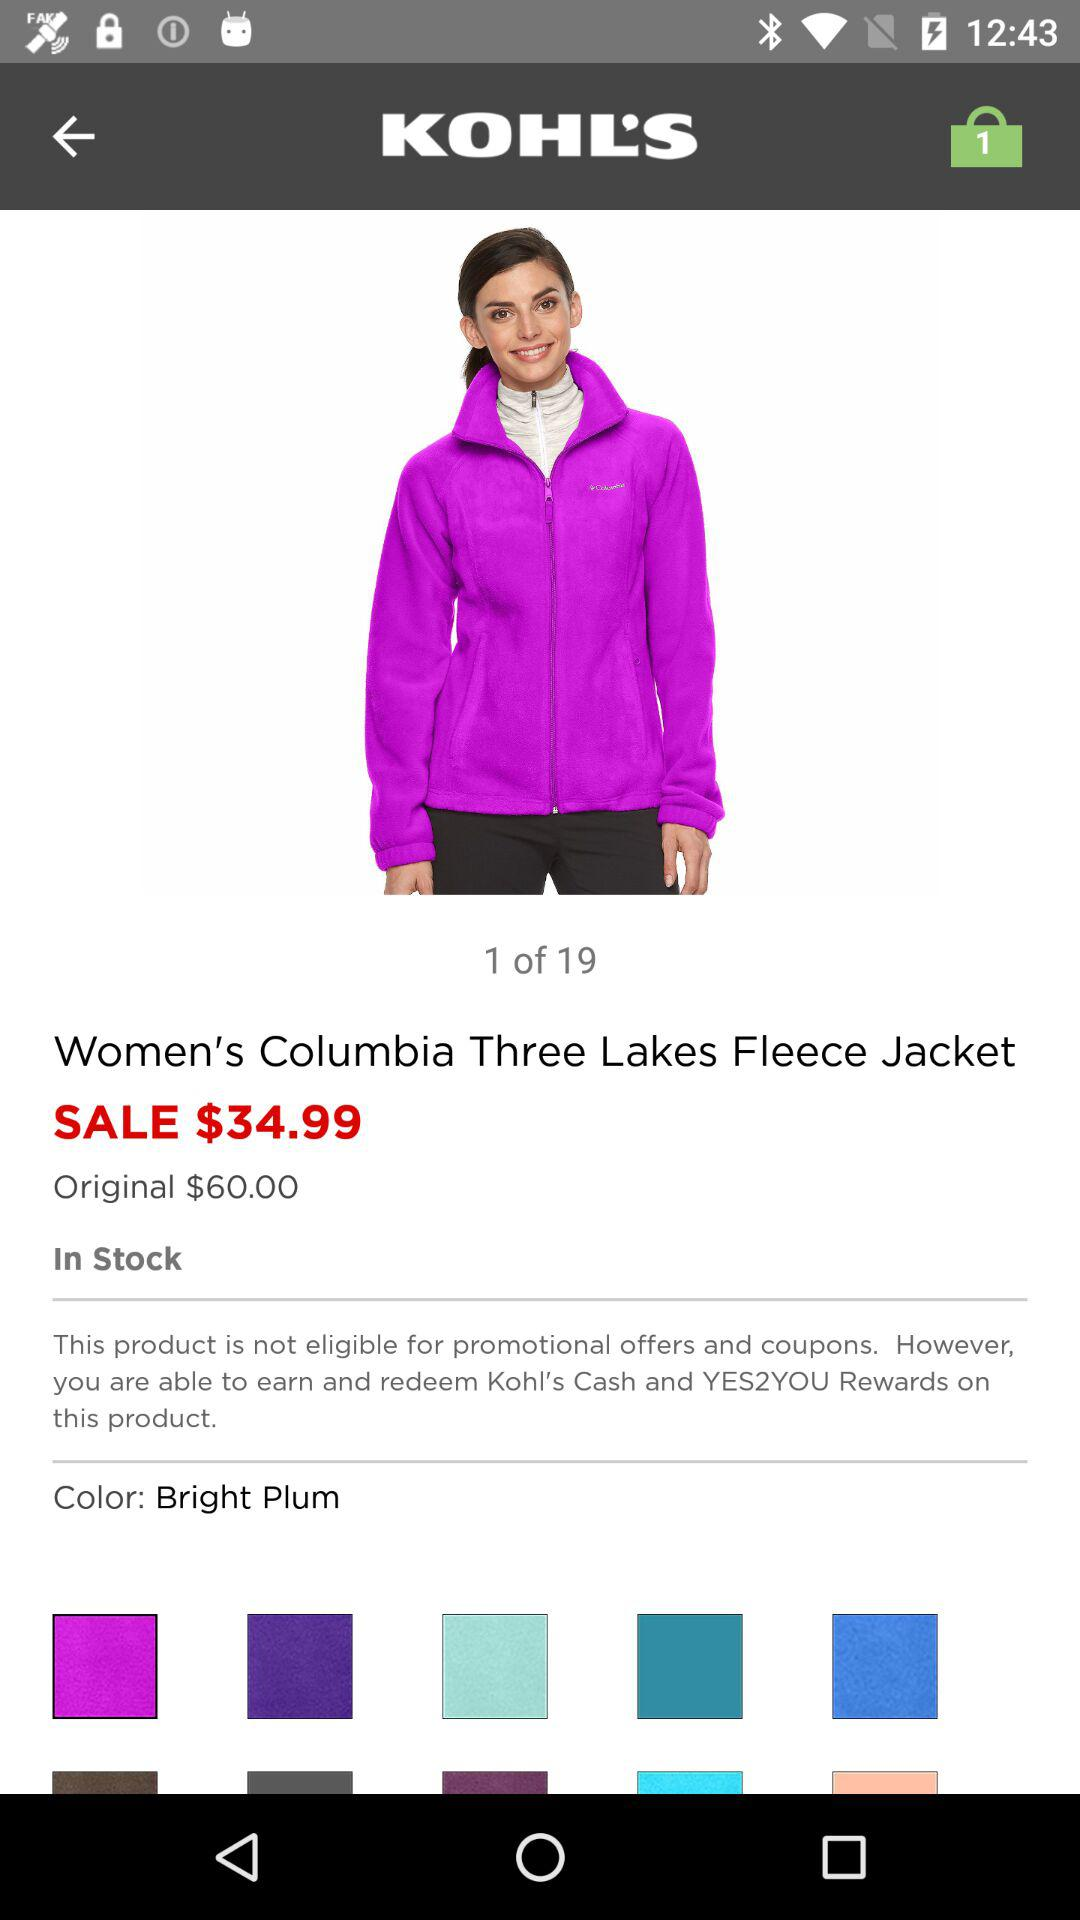How much is the original price of the product?
Answer the question using a single word or phrase. $60.00 